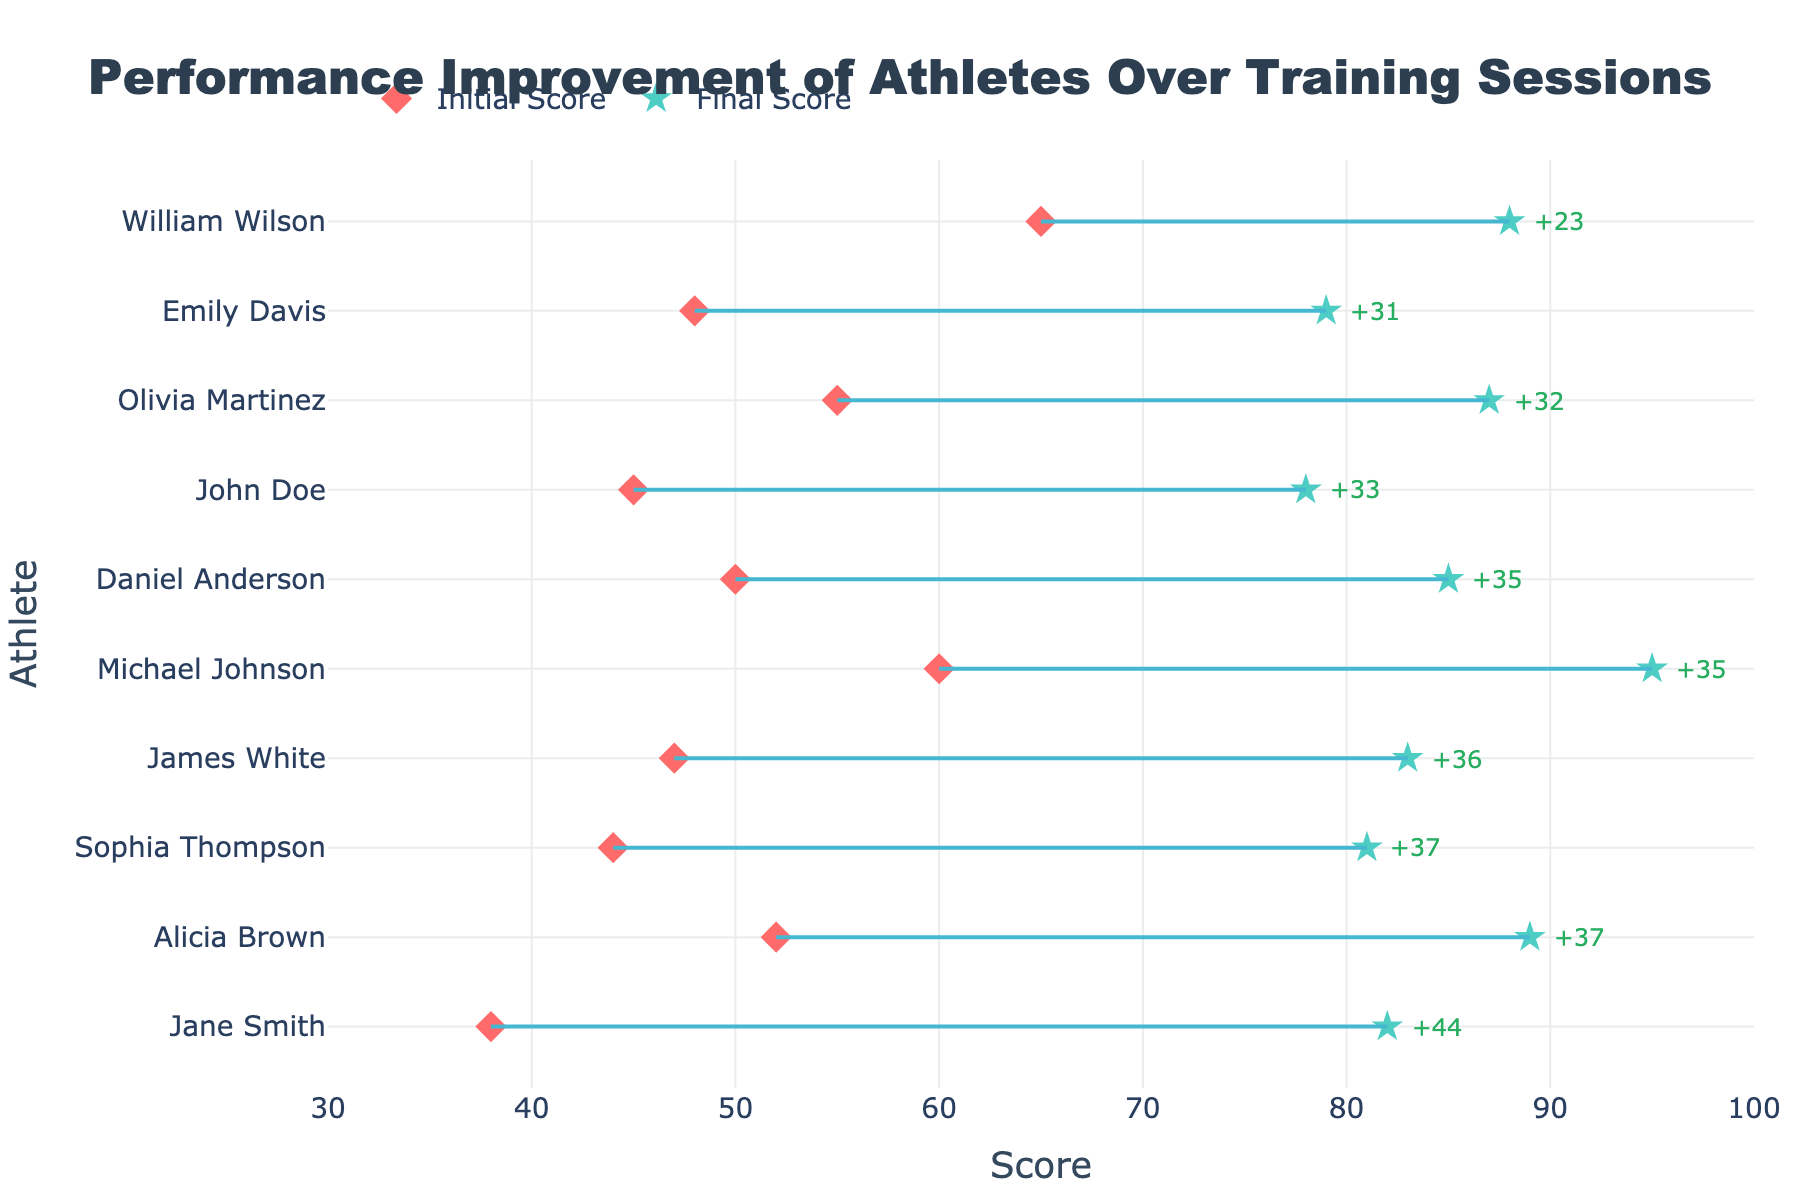What's the title of the figure? The title is displayed at the top of the plot in a bigger and bolder font. Here, the title clearly indicates the content of the plot.
Answer: Performance Improvement of Athletes Over Training Sessions What is the color of the markers representing the Final Score? The Final Score markers can be identified by their unique symbol and color. They are star-shaped and colored in a minty green, which stands out from the red diamond-shaped Initial Score markers.
Answer: Minty Green Which athlete has the most significant improvement in performance? To find the athlete with the most significant improvement, look for the longest line connecting the initial and final scores. It should also have the highest numerical improvement annotation.
Answer: Michael Johnson What is Sophia Thompson's improvement in score? Look for Sophia Thompson in the figure, and check the annotation next to her final score marker to see the improvement.
Answer: 37 points Between Olivia Martinez and James White, who had a higher final score? Compare the x-axis positions of the final score markers for both Olivia Martinez and James White. The one with the marker further to the right on the x-axis has the higher final score.
Answer: James White What is the score range covered by the x-axis? The x-axis represents the scores and has ticks from 30 to 100.
Answer: 30 to 100 Find the athlete with the smallest improvement in performance. To determine the athlete with the smallest improvement, look for the shortest line connecting initial and final scores.
Answer: William Wilson How many athletes have an initial score above 50? Count the number of red diamond markers that are positioned to the right of the 50 mark on the x-axis.
Answer: 5 athletes Calculate the average initial score of all athletes. Sum all initial scores (45 + 38 + 52 + 60 + 48 + 65 + 55 + 50 + 44 + 47) and divide by the total number of athletes (10).
Answer: 50.4 Which athlete had the highest initial score and what was it? Identify the athlete whose red diamond marker is the furthest to the right on the x-axis, which represents the scores.
Answer: William Wilson with 65 points 